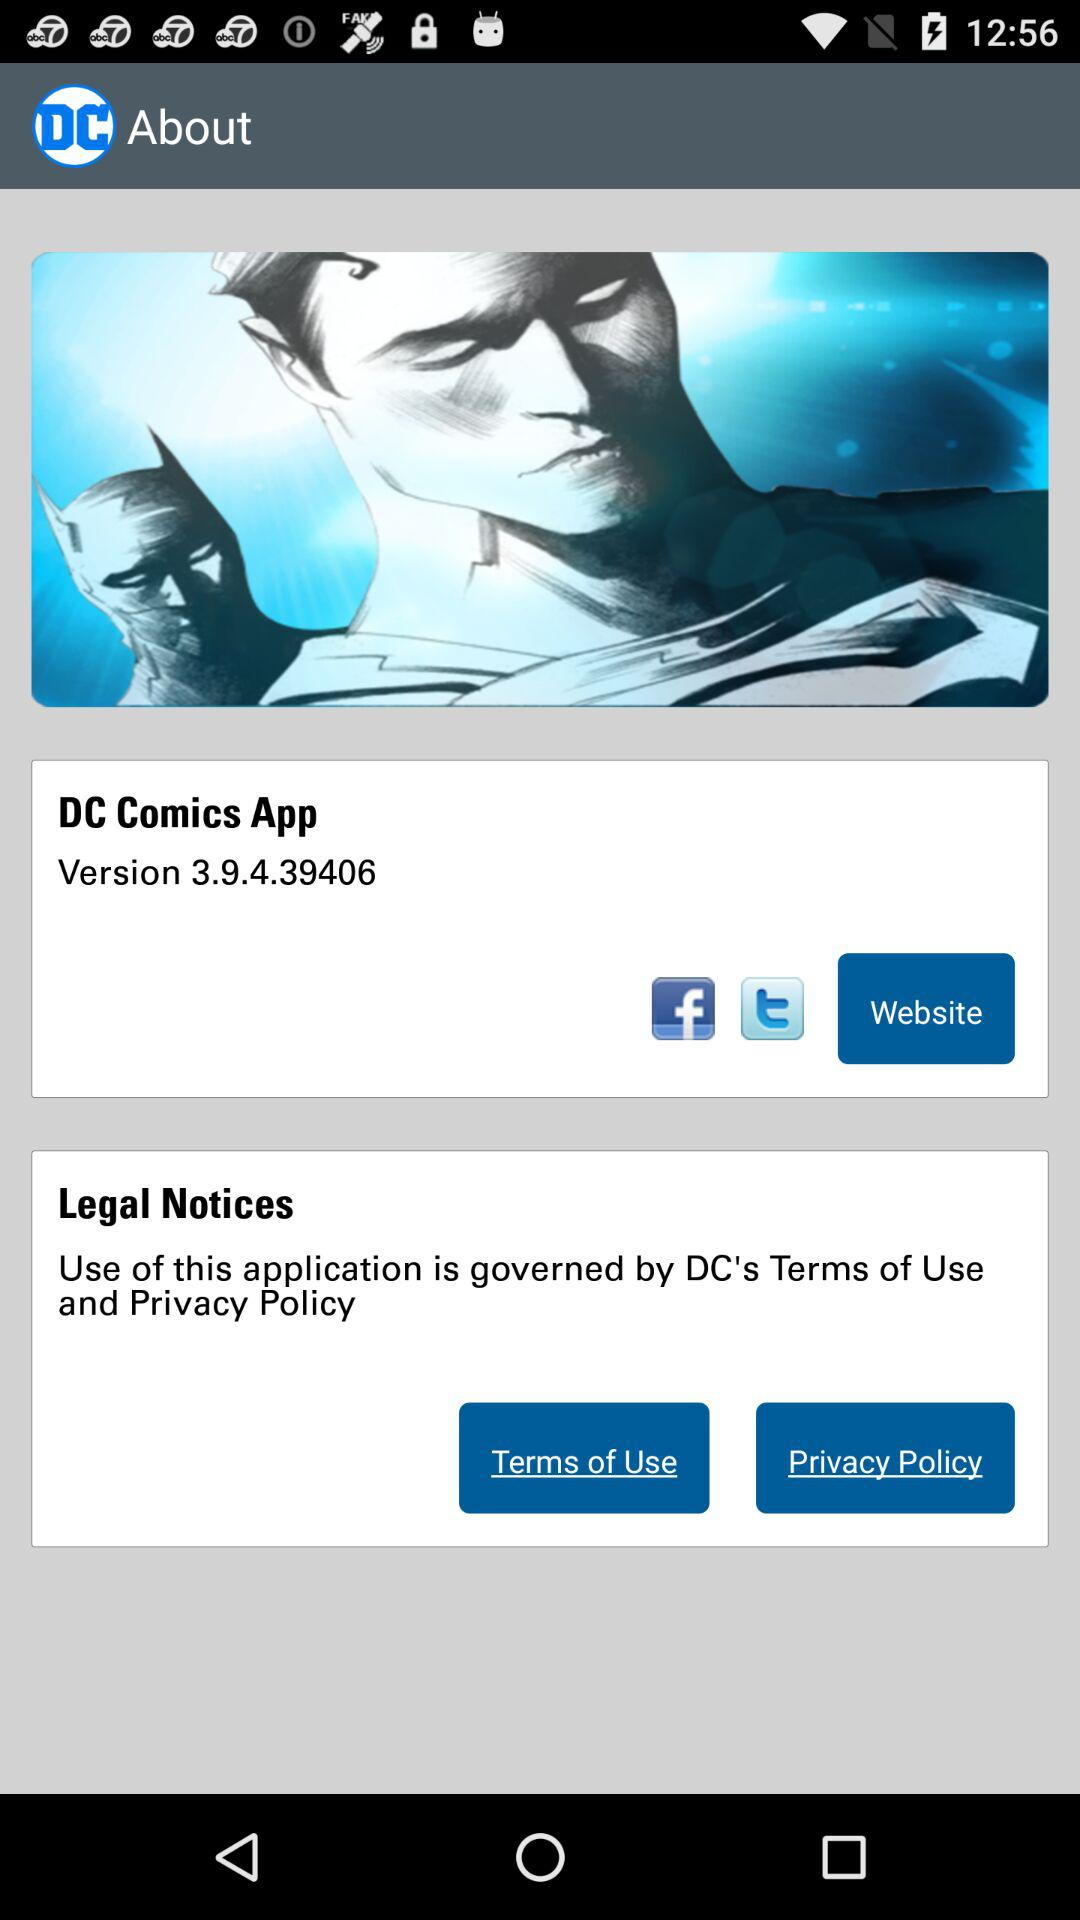Which option is given to open it? The given options are "Facebook", "Twitter" and "Website". 